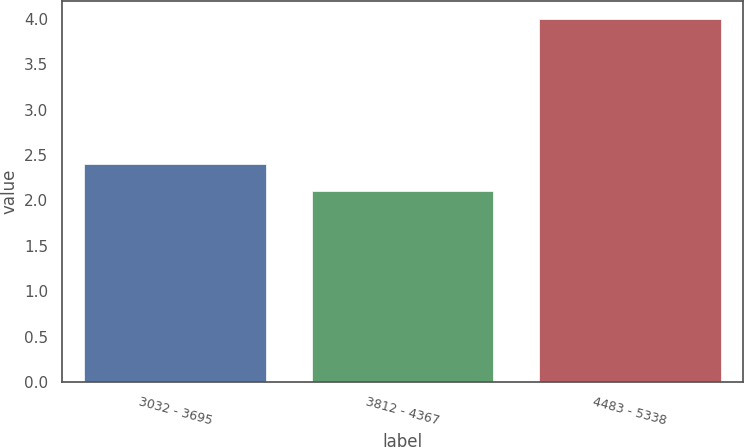<chart> <loc_0><loc_0><loc_500><loc_500><bar_chart><fcel>3032 - 3695<fcel>3812 - 4367<fcel>4483 - 5338<nl><fcel>2.4<fcel>2.1<fcel>4<nl></chart> 